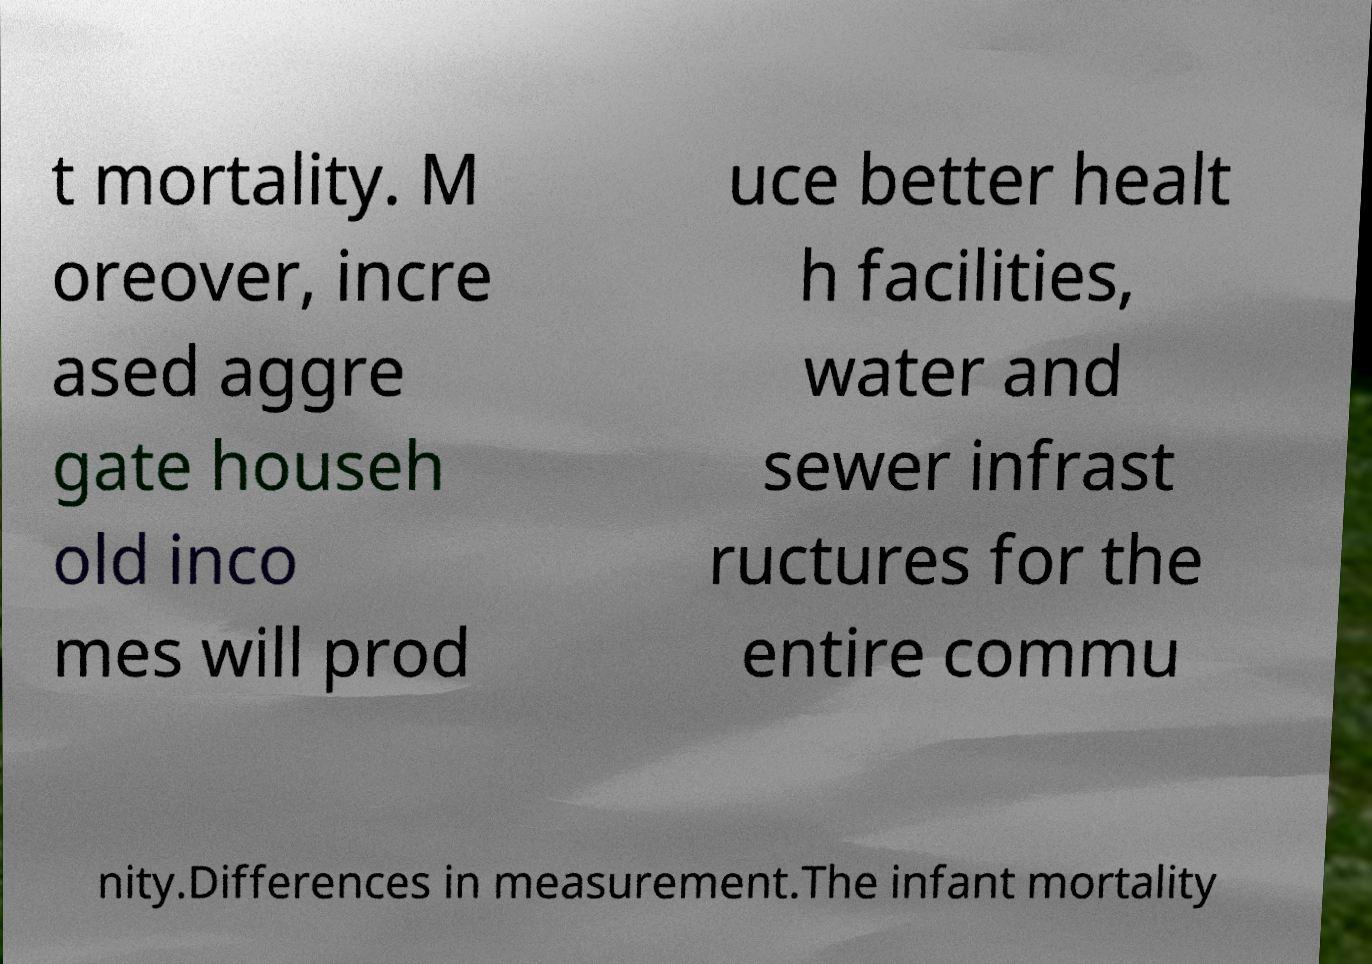For documentation purposes, I need the text within this image transcribed. Could you provide that? t mortality. M oreover, incre ased aggre gate househ old inco mes will prod uce better healt h facilities, water and sewer infrast ructures for the entire commu nity.Differences in measurement.The infant mortality 